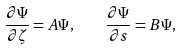Convert formula to latex. <formula><loc_0><loc_0><loc_500><loc_500>\frac { \partial \Psi } { \partial \zeta } = A \Psi , \quad \frac { \partial \Psi } { \partial s } = B \Psi ,</formula> 